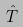<formula> <loc_0><loc_0><loc_500><loc_500>\hat { T }</formula> 